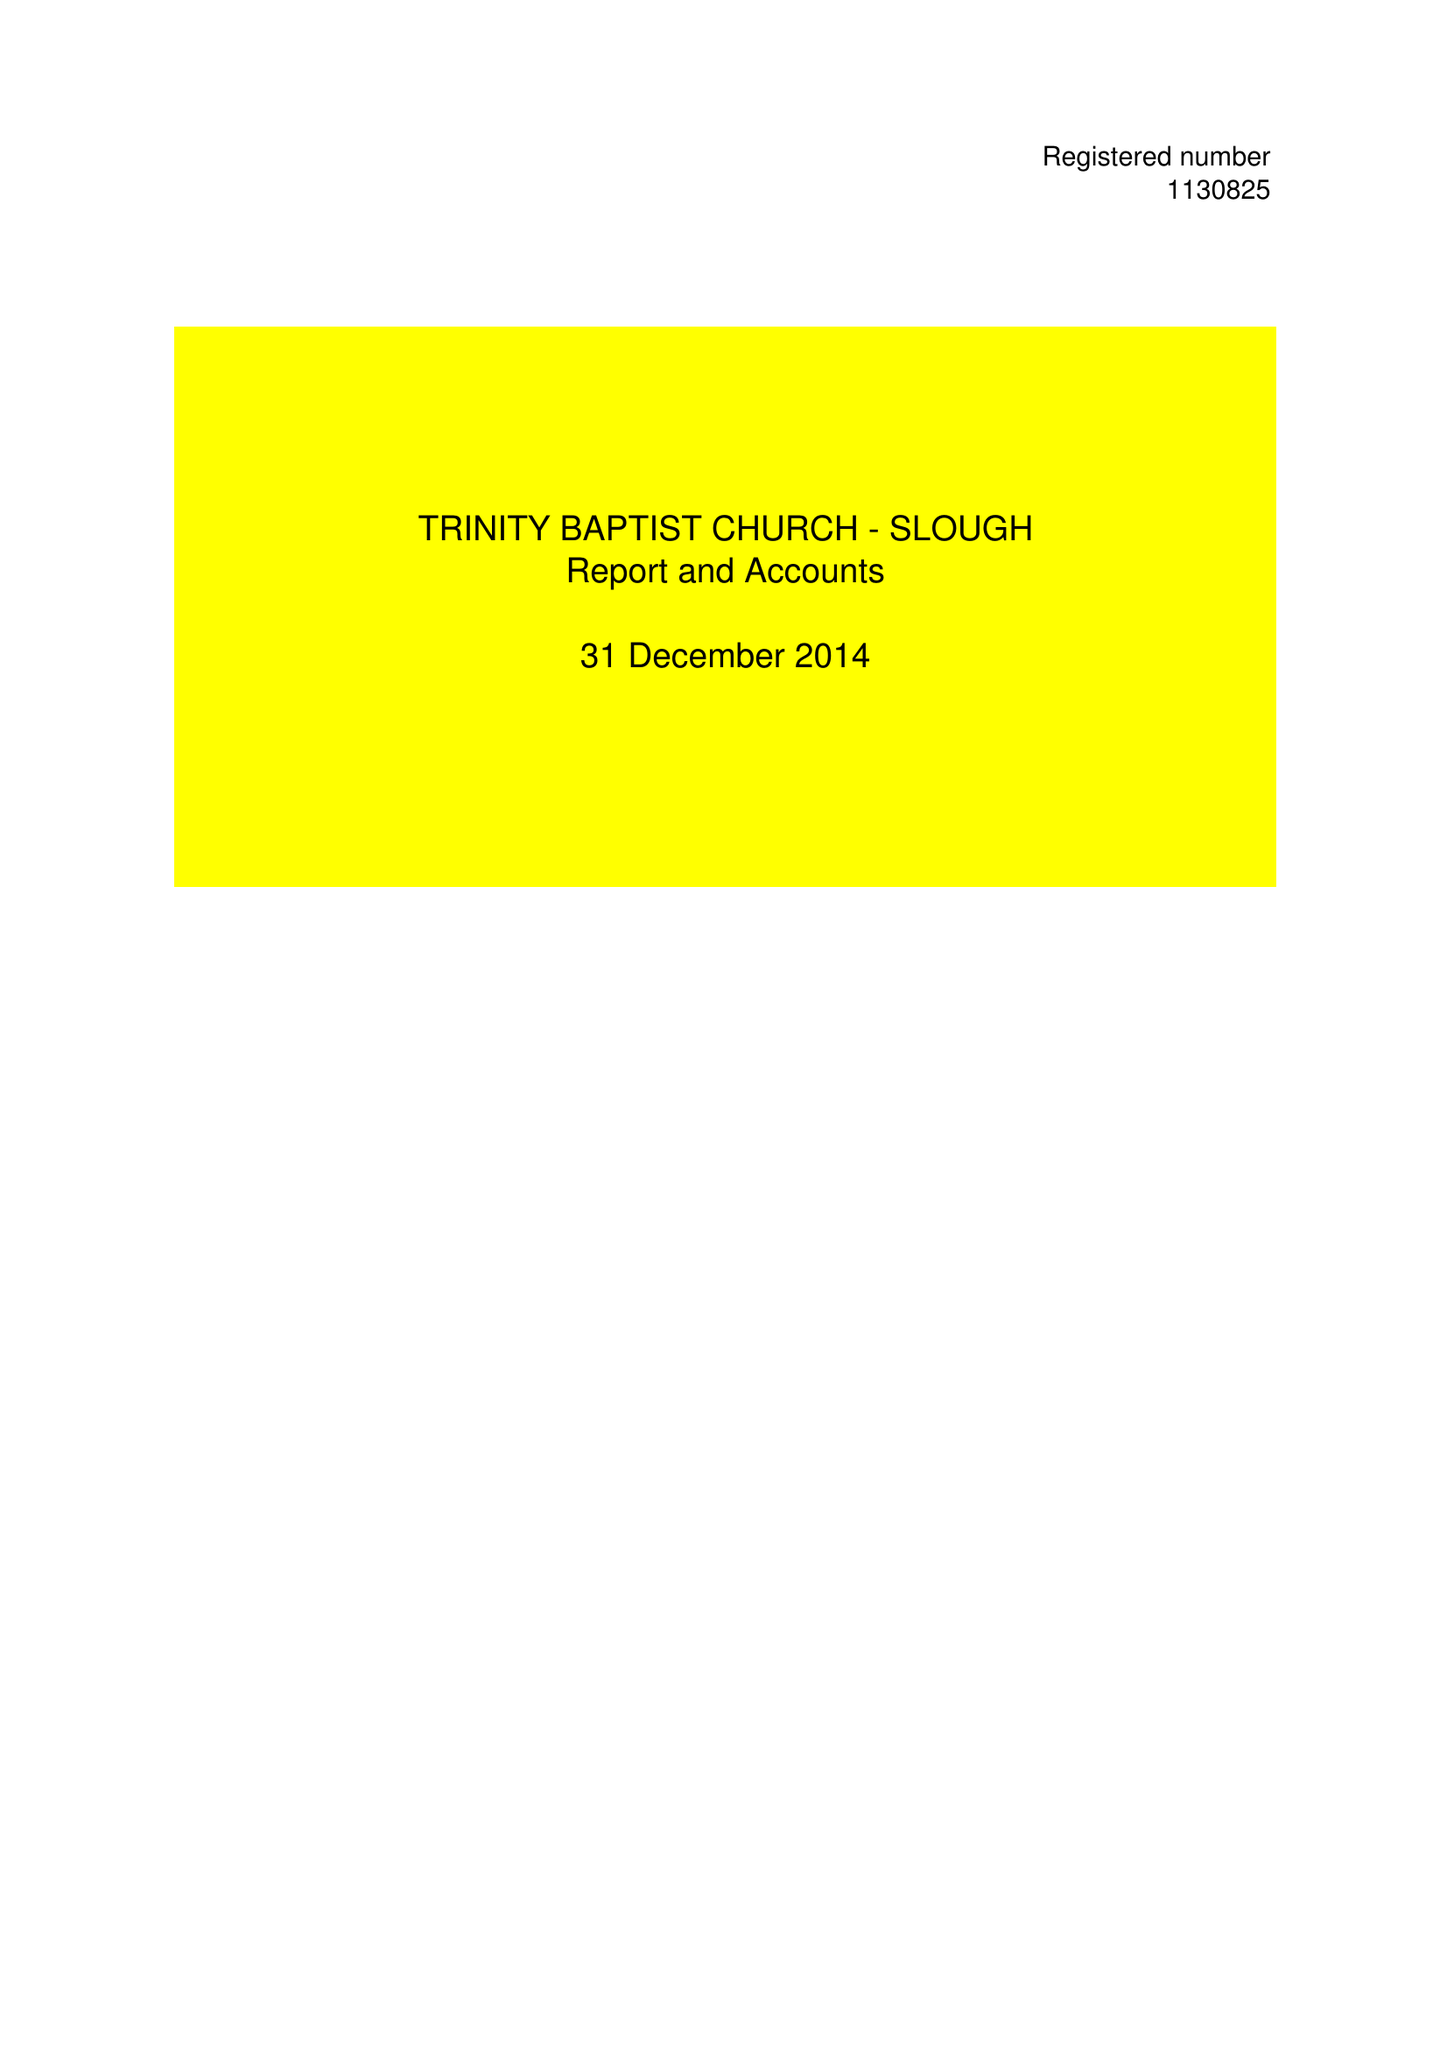What is the value for the address__street_line?
Answer the question using a single word or phrase. 76 GLAMORGAN CLOSE 